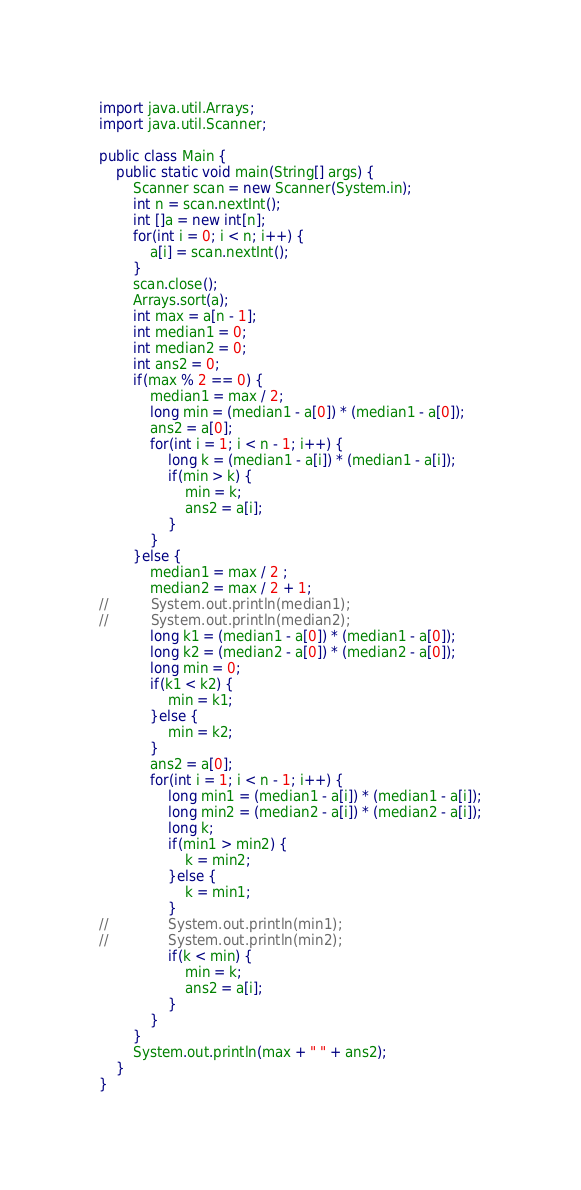Convert code to text. <code><loc_0><loc_0><loc_500><loc_500><_Java_>import java.util.Arrays;
import java.util.Scanner;

public class Main {
	public static void main(String[] args) {
		Scanner scan = new Scanner(System.in);
		int n = scan.nextInt();
		int []a = new int[n];
		for(int i = 0; i < n; i++) {
			a[i] = scan.nextInt();
		}
		scan.close();
		Arrays.sort(a);
		int max = a[n - 1];
		int median1 = 0;
		int median2 = 0;
		int ans2 = 0;
		if(max % 2 == 0) {
			median1 = max / 2;
			long min = (median1 - a[0]) * (median1 - a[0]);
			ans2 = a[0];
			for(int i = 1; i < n - 1; i++) {
				long k = (median1 - a[i]) * (median1 - a[i]);
				if(min > k) {
					min = k;
					ans2 = a[i];
				}
			}
		}else {
			median1 = max / 2 ;
			median2 = max / 2 + 1;
//			System.out.println(median1);
//			System.out.println(median2);
			long k1 = (median1 - a[0]) * (median1 - a[0]);
			long k2 = (median2 - a[0]) * (median2 - a[0]);
			long min = 0;
			if(k1 < k2) {
				min = k1;
			}else {
				min = k2;
			}
			ans2 = a[0];
			for(int i = 1; i < n - 1; i++) {
				long min1 = (median1 - a[i]) * (median1 - a[i]);
				long min2 = (median2 - a[i]) * (median2 - a[i]);
				long k;
				if(min1 > min2) {
					k = min2;
				}else {
					k = min1;
				}
//				System.out.println(min1);
//				System.out.println(min2);
				if(k < min) {
					min = k;
					ans2 = a[i];
				}
			}
		}
		System.out.println(max + " " + ans2);
	}
}</code> 